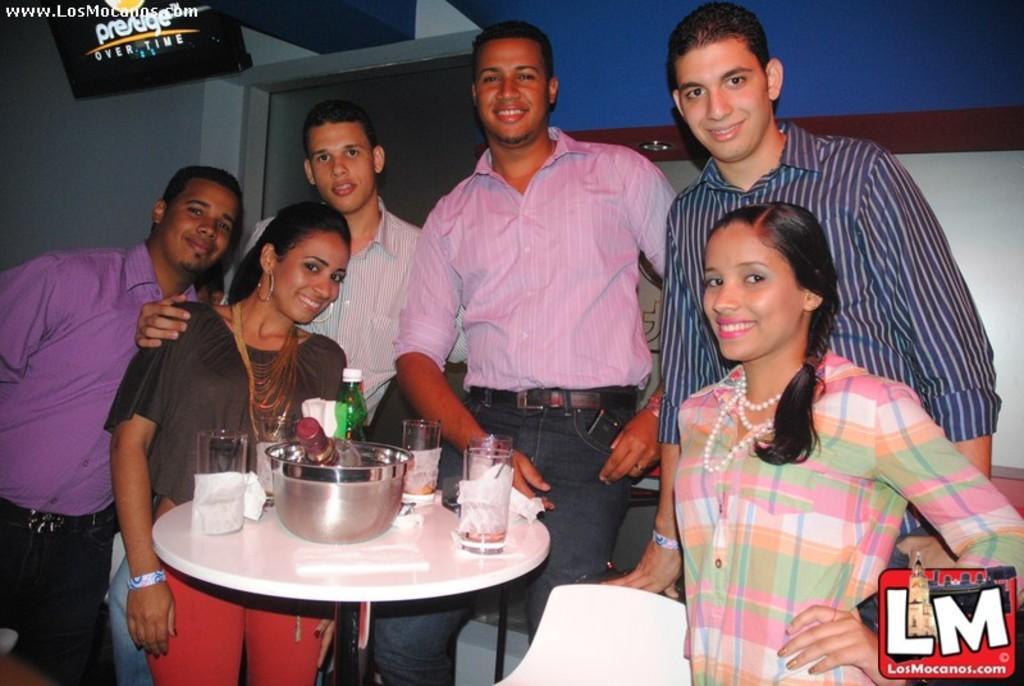Please provide a concise description of this image. In the center of the image there is a table and there are people standing around the table. There is a chair. There are bowls, glasses, bottles, napkins which are placed on the table. In the background there is a wall and a door. 